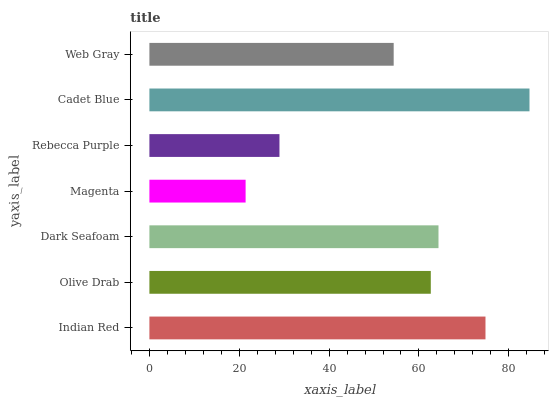Is Magenta the minimum?
Answer yes or no. Yes. Is Cadet Blue the maximum?
Answer yes or no. Yes. Is Olive Drab the minimum?
Answer yes or no. No. Is Olive Drab the maximum?
Answer yes or no. No. Is Indian Red greater than Olive Drab?
Answer yes or no. Yes. Is Olive Drab less than Indian Red?
Answer yes or no. Yes. Is Olive Drab greater than Indian Red?
Answer yes or no. No. Is Indian Red less than Olive Drab?
Answer yes or no. No. Is Olive Drab the high median?
Answer yes or no. Yes. Is Olive Drab the low median?
Answer yes or no. Yes. Is Dark Seafoam the high median?
Answer yes or no. No. Is Indian Red the low median?
Answer yes or no. No. 